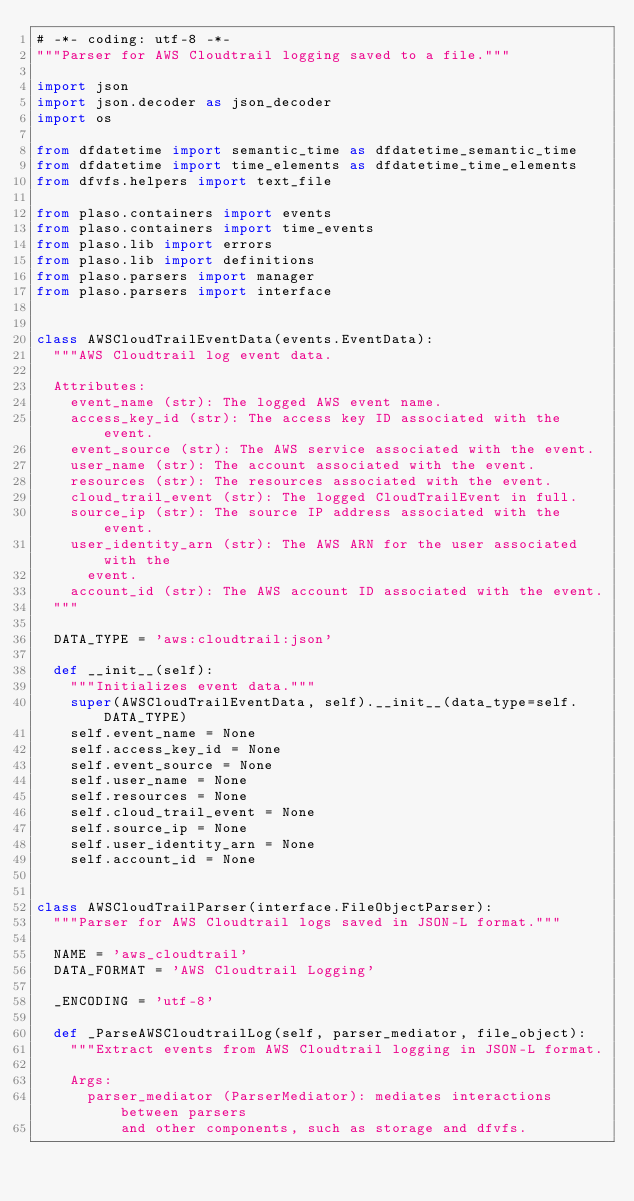<code> <loc_0><loc_0><loc_500><loc_500><_Python_># -*- coding: utf-8 -*-
"""Parser for AWS Cloudtrail logging saved to a file."""

import json
import json.decoder as json_decoder
import os

from dfdatetime import semantic_time as dfdatetime_semantic_time
from dfdatetime import time_elements as dfdatetime_time_elements
from dfvfs.helpers import text_file

from plaso.containers import events
from plaso.containers import time_events
from plaso.lib import errors
from plaso.lib import definitions
from plaso.parsers import manager
from plaso.parsers import interface


class AWSCloudTrailEventData(events.EventData):
  """AWS Cloudtrail log event data.

  Attributes:
    event_name (str): The logged AWS event name.
    access_key_id (str): The access key ID associated with the event.
    event_source (str): The AWS service associated with the event.
    user_name (str): The account associated with the event.
    resources (str): The resources associated with the event.
    cloud_trail_event (str): The logged CloudTrailEvent in full.
    source_ip (str): The source IP address associated with the event.
    user_identity_arn (str): The AWS ARN for the user associated with the
      event.
    account_id (str): The AWS account ID associated with the event.
  """

  DATA_TYPE = 'aws:cloudtrail:json'

  def __init__(self):
    """Initializes event data."""
    super(AWSCloudTrailEventData, self).__init__(data_type=self.DATA_TYPE)
    self.event_name = None
    self.access_key_id = None
    self.event_source = None
    self.user_name = None
    self.resources = None
    self.cloud_trail_event = None
    self.source_ip = None
    self.user_identity_arn = None
    self.account_id = None


class AWSCloudTrailParser(interface.FileObjectParser):
  """Parser for AWS Cloudtrail logs saved in JSON-L format."""

  NAME = 'aws_cloudtrail'
  DATA_FORMAT = 'AWS Cloudtrail Logging'

  _ENCODING = 'utf-8'

  def _ParseAWSCloudtrailLog(self, parser_mediator, file_object):
    """Extract events from AWS Cloudtrail logging in JSON-L format.

    Args:
      parser_mediator (ParserMediator): mediates interactions between parsers
          and other components, such as storage and dfvfs.</code> 